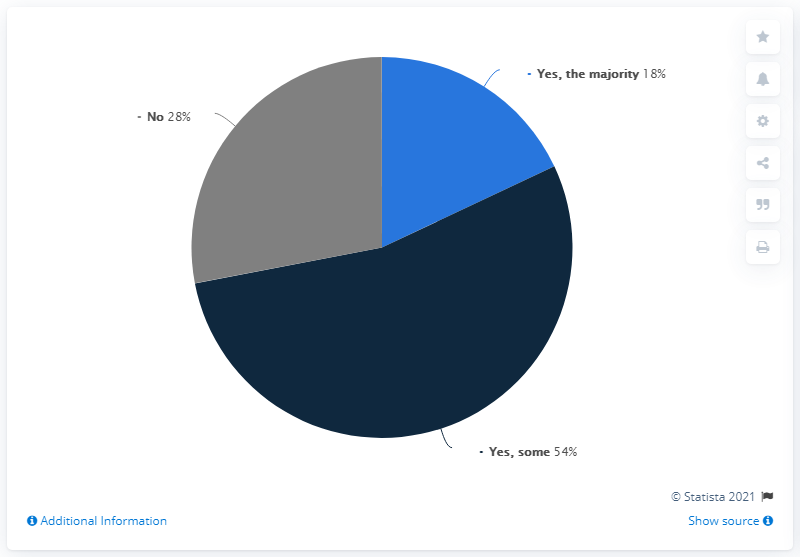Identify some key points in this picture. Seventy-two people say "yes. In a democratic voting system, the terms "yes," "the majority," and "no" are used to indicate approval or rejection of a proposal. The difference between these terms lies in the level of support required for a decision to be made. 